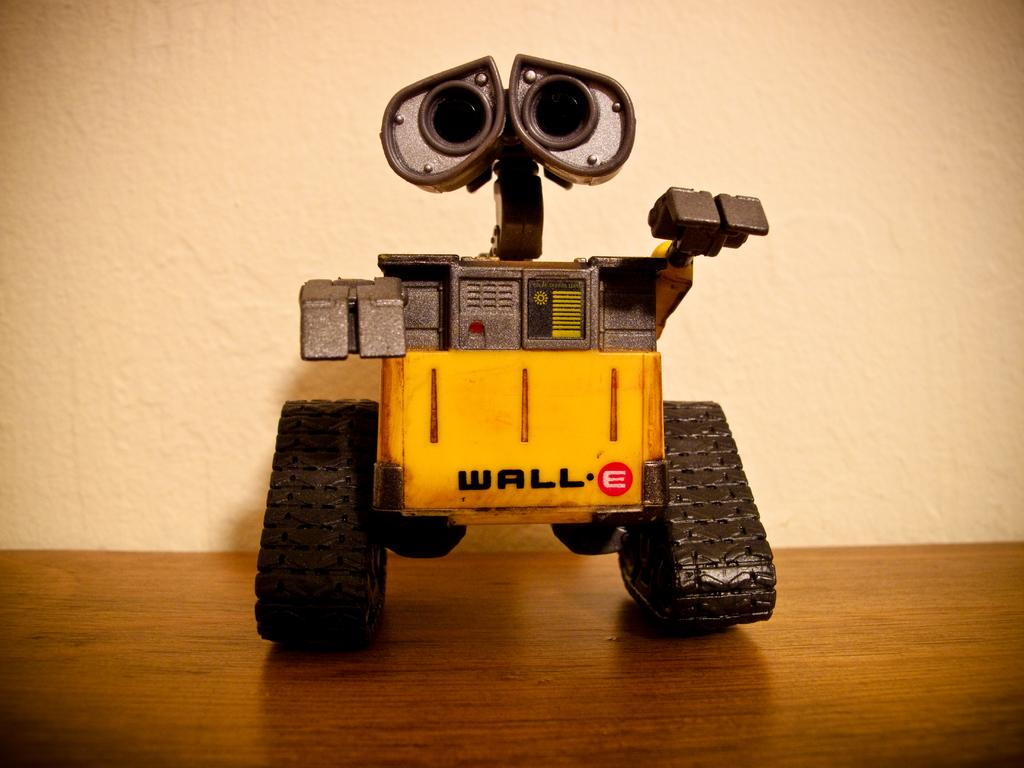What type of object is in the image? There is a toy vehicle in the image. Where is the toy vehicle located? The toy vehicle is on a table. What can be seen in the background of the image? There is a wall visible in the background of the image. What type of cake is being served in the alley behind the wall in the image? There is no cake or alley present in the image; it only features a toy vehicle on a table with a wall visible in the background. 